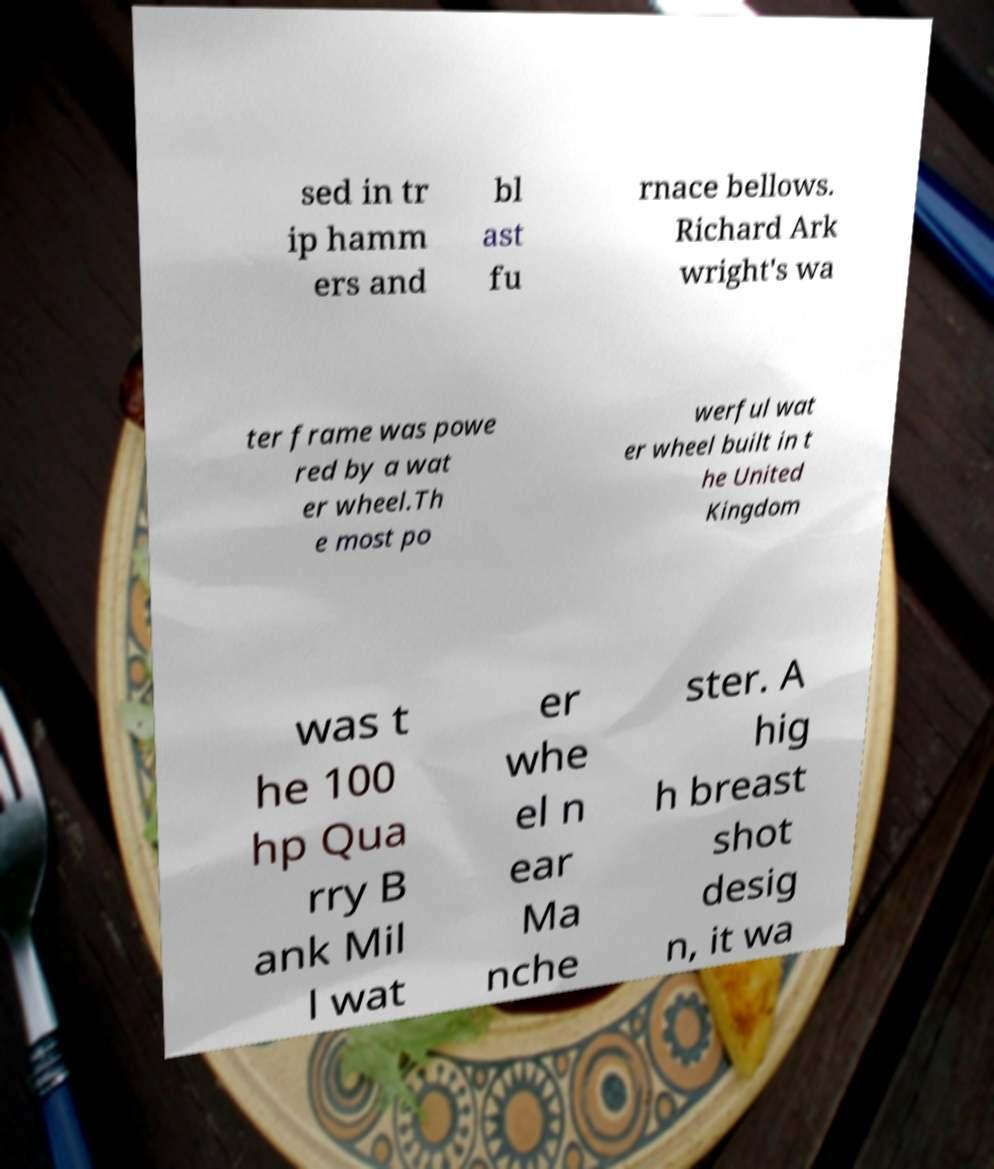Please identify and transcribe the text found in this image. sed in tr ip hamm ers and bl ast fu rnace bellows. Richard Ark wright's wa ter frame was powe red by a wat er wheel.Th e most po werful wat er wheel built in t he United Kingdom was t he 100 hp Qua rry B ank Mil l wat er whe el n ear Ma nche ster. A hig h breast shot desig n, it wa 